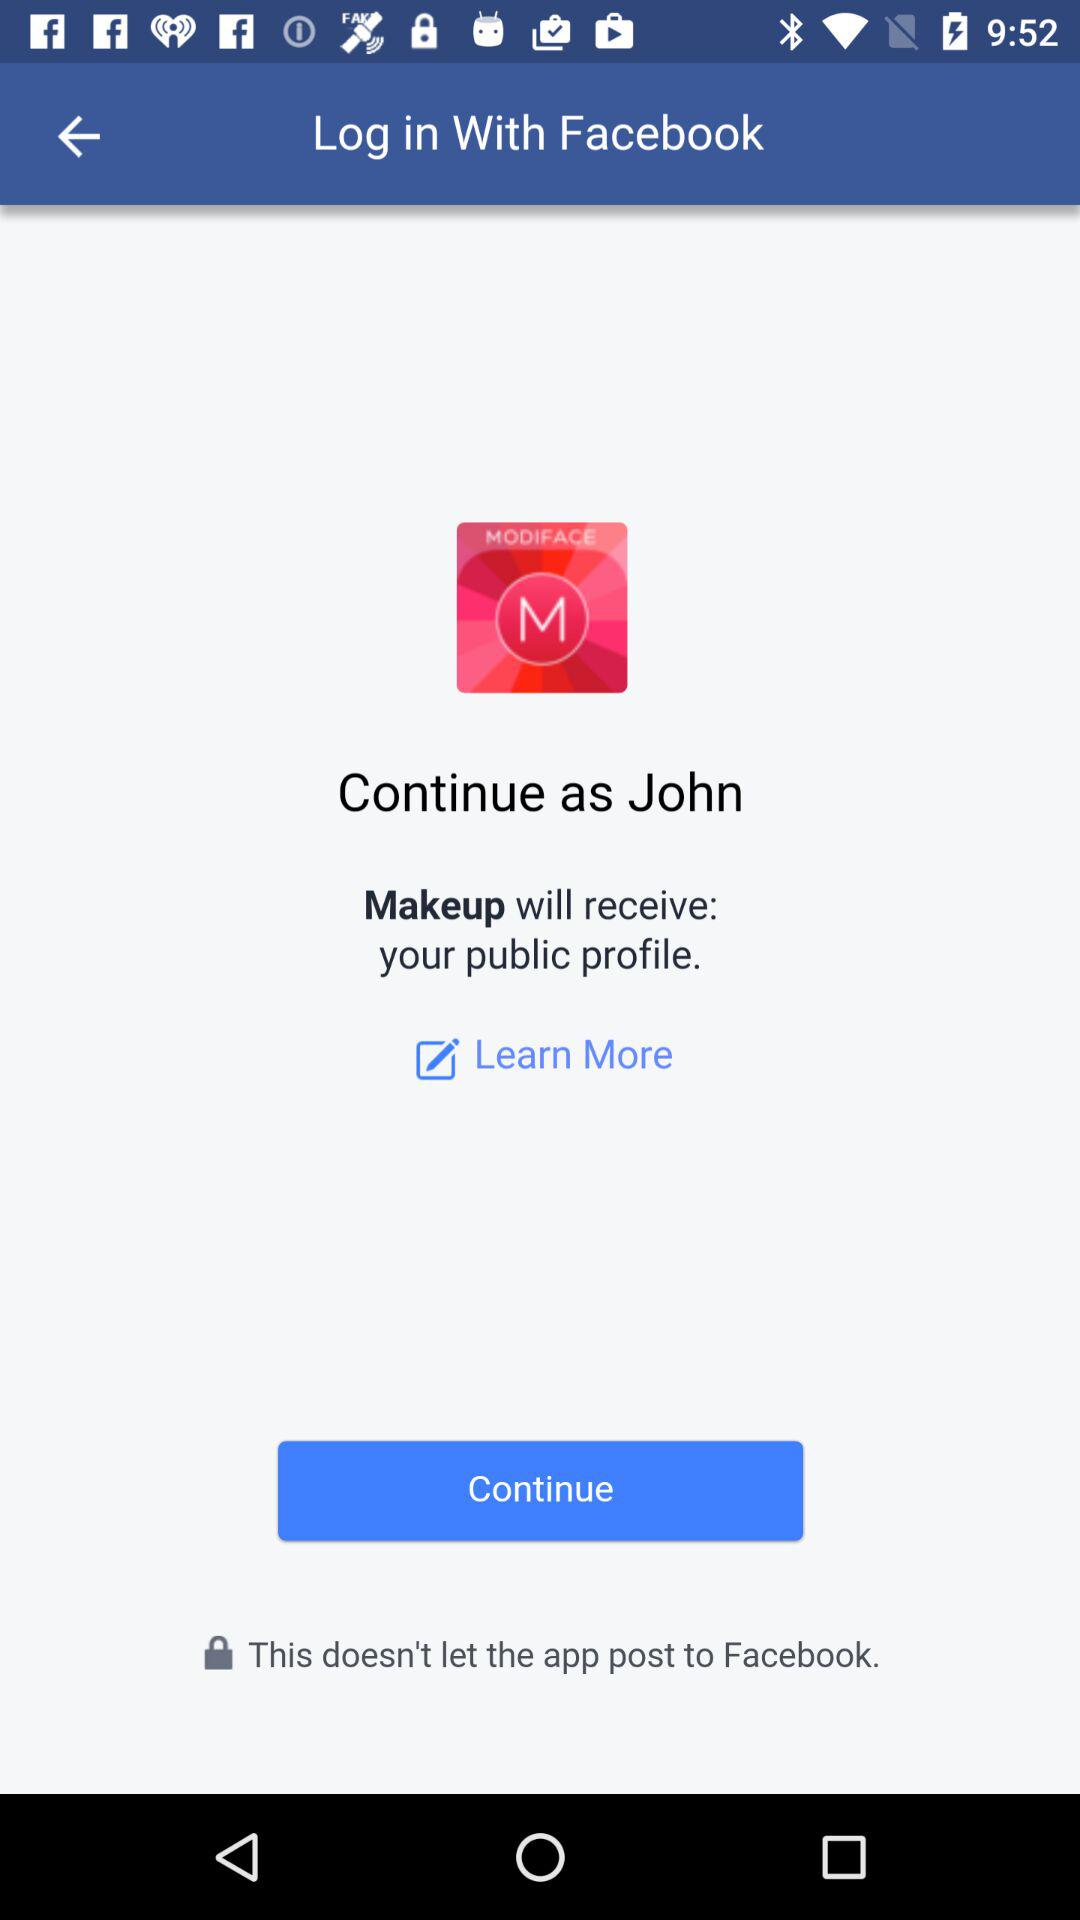What is the name of the application? The name of the application is "Makeup". 